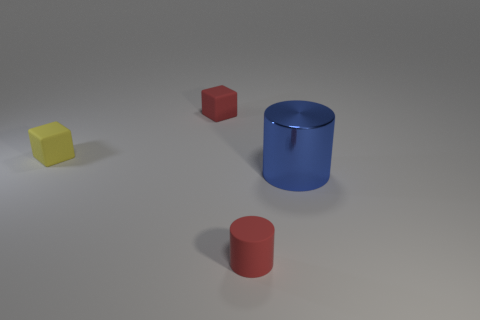Are there any other things of the same color as the large cylinder?
Make the answer very short. No. Does the red object that is behind the small red matte cylinder have the same size as the cylinder that is behind the tiny cylinder?
Your answer should be very brief. No. Is the number of yellow cubes to the right of the yellow rubber thing the same as the number of matte things behind the tiny red cylinder?
Ensure brevity in your answer.  No. Does the blue thing have the same size as the rubber object that is in front of the large shiny object?
Provide a short and direct response. No. Are there any tiny yellow matte objects that are behind the tiny red thing that is in front of the metal thing?
Your response must be concise. Yes. Is there a red rubber thing of the same shape as the large shiny object?
Provide a short and direct response. Yes. What number of small things are in front of the red matte thing left of the cylinder that is in front of the big object?
Keep it short and to the point. 2. Do the large cylinder and the tiny matte thing behind the yellow object have the same color?
Your answer should be very brief. No. How many things are small things on the right side of the red matte block or things that are on the left side of the red cube?
Your answer should be very brief. 2. Are there more rubber things that are left of the tiny red cube than red cylinders right of the blue cylinder?
Offer a very short reply. Yes. 